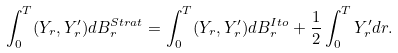<formula> <loc_0><loc_0><loc_500><loc_500>\int _ { 0 } ^ { T } ( Y _ { r } , Y _ { r } ^ { \prime } ) d B _ { r } ^ { S t r a t } = \int _ { 0 } ^ { T } ( Y _ { r } , Y _ { r } ^ { \prime } ) d B _ { r } ^ { I t o } + \frac { 1 } { 2 } \int _ { 0 } ^ { T } Y _ { r } ^ { \prime } d r .</formula> 